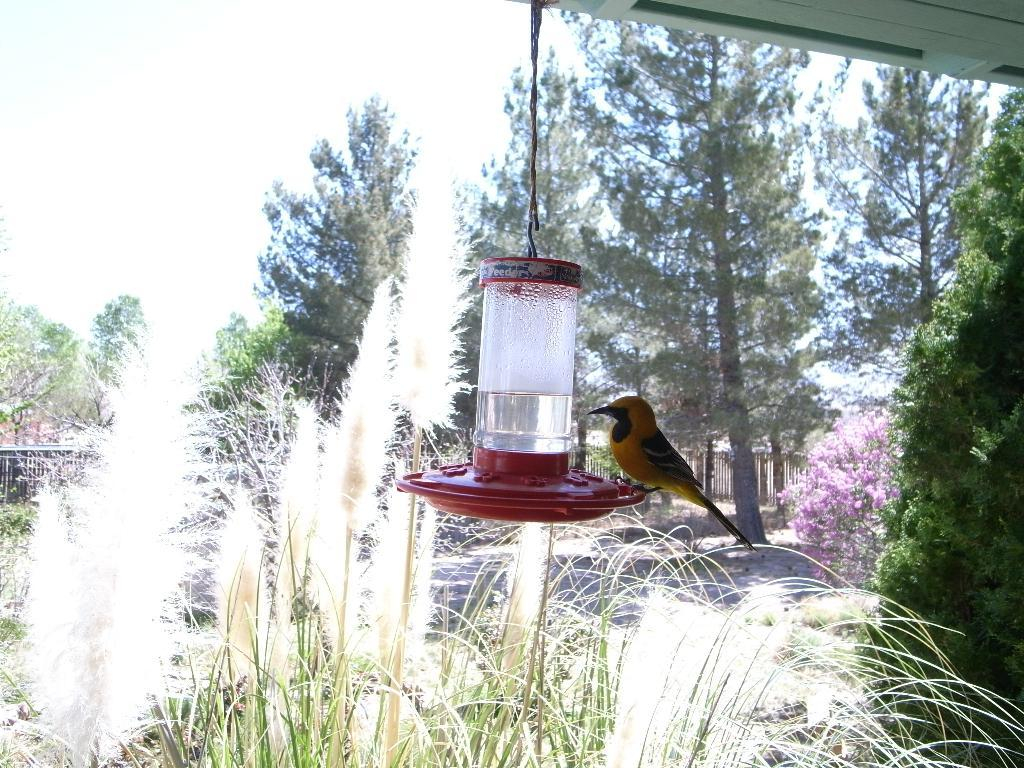What type of bird is in the center of the image? There is a goldfinch in the center of the image. Can you describe the interaction between the goldfinch and the other bird? There is another bird on the goldfinch. What can be seen in the background of the image? There is a boundary and greenery in the background of the image. What type of pancake is being prepared by the ladybug in the image? There is no ladybug or pancake present in the image. What is the carpenter doing in the image? There is no carpenter present in the image. 